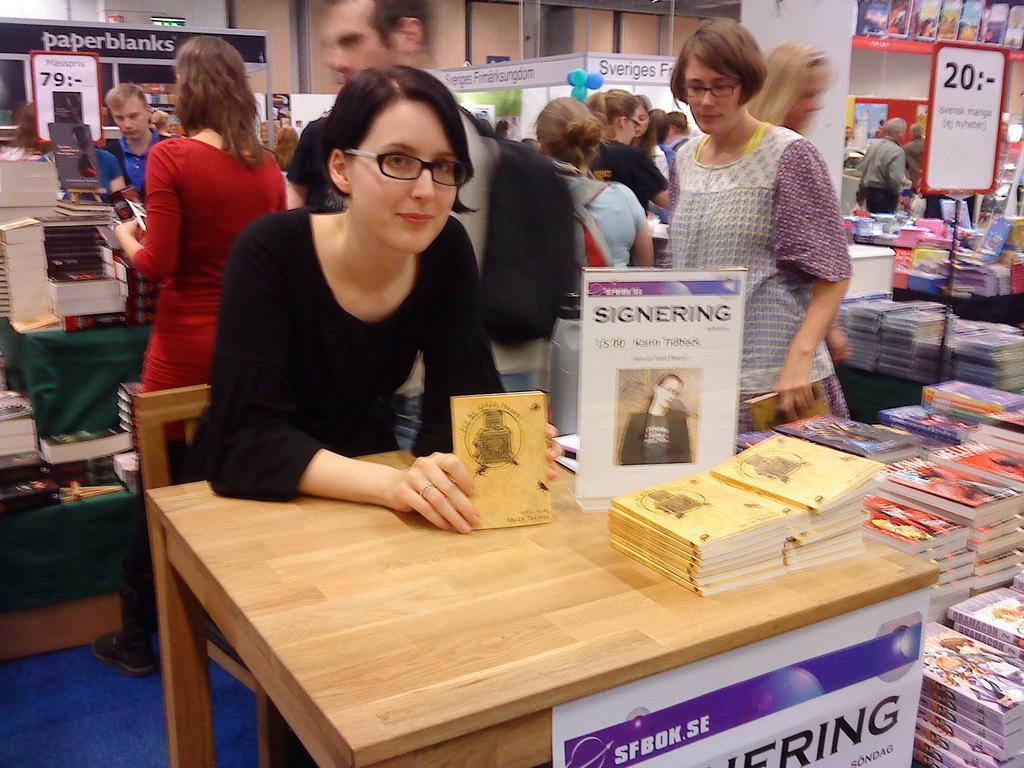Could you give a brief overview of what you see in this image? In this image I can see there are group of people, among them a woman who is wearing a black dress is sitting on a chair in front of the table. On the table we have couple of books on it. On the right side we can see there is a board and a shelf with some products in it. 